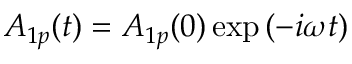<formula> <loc_0><loc_0><loc_500><loc_500>A _ { 1 p } ( t ) = A _ { 1 p } ( 0 ) \exp { ( - i \omega t ) }</formula> 